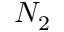<formula> <loc_0><loc_0><loc_500><loc_500>N _ { 2 }</formula> 